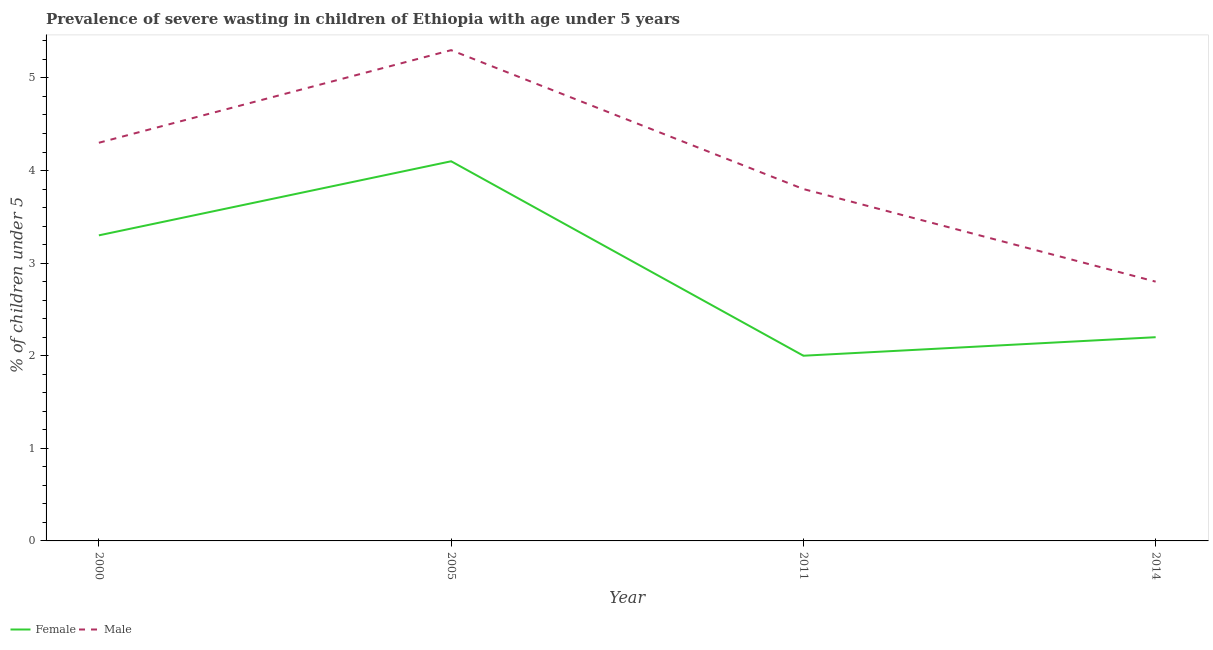What is the percentage of undernourished male children in 2000?
Provide a succinct answer. 4.3. Across all years, what is the maximum percentage of undernourished female children?
Offer a terse response. 4.1. Across all years, what is the minimum percentage of undernourished female children?
Provide a short and direct response. 2. In which year was the percentage of undernourished male children minimum?
Provide a succinct answer. 2014. What is the total percentage of undernourished female children in the graph?
Ensure brevity in your answer.  11.6. What is the difference between the percentage of undernourished female children in 2000 and that in 2014?
Offer a terse response. 1.1. What is the difference between the percentage of undernourished female children in 2014 and the percentage of undernourished male children in 2000?
Offer a terse response. -2.1. What is the average percentage of undernourished male children per year?
Your answer should be very brief. 4.05. In the year 2005, what is the difference between the percentage of undernourished male children and percentage of undernourished female children?
Provide a succinct answer. 1.2. What is the ratio of the percentage of undernourished female children in 2000 to that in 2005?
Your response must be concise. 0.8. Is the percentage of undernourished male children in 2000 less than that in 2005?
Provide a succinct answer. Yes. What is the difference between the highest and the second highest percentage of undernourished male children?
Make the answer very short. 1. What is the difference between the highest and the lowest percentage of undernourished female children?
Offer a terse response. 2.1. In how many years, is the percentage of undernourished female children greater than the average percentage of undernourished female children taken over all years?
Provide a succinct answer. 2. Is the percentage of undernourished male children strictly less than the percentage of undernourished female children over the years?
Your answer should be compact. No. How many lines are there?
Your answer should be very brief. 2. Are the values on the major ticks of Y-axis written in scientific E-notation?
Make the answer very short. No. Does the graph contain any zero values?
Provide a succinct answer. No. Does the graph contain grids?
Provide a short and direct response. No. How are the legend labels stacked?
Make the answer very short. Horizontal. What is the title of the graph?
Offer a terse response. Prevalence of severe wasting in children of Ethiopia with age under 5 years. Does "Girls" appear as one of the legend labels in the graph?
Offer a very short reply. No. What is the label or title of the Y-axis?
Offer a terse response.  % of children under 5. What is the  % of children under 5 of Female in 2000?
Offer a very short reply. 3.3. What is the  % of children under 5 of Male in 2000?
Give a very brief answer. 4.3. What is the  % of children under 5 of Female in 2005?
Make the answer very short. 4.1. What is the  % of children under 5 in Male in 2005?
Offer a terse response. 5.3. What is the  % of children under 5 of Male in 2011?
Offer a very short reply. 3.8. What is the  % of children under 5 of Female in 2014?
Keep it short and to the point. 2.2. What is the  % of children under 5 in Male in 2014?
Provide a short and direct response. 2.8. Across all years, what is the maximum  % of children under 5 in Female?
Your answer should be compact. 4.1. Across all years, what is the maximum  % of children under 5 of Male?
Offer a terse response. 5.3. Across all years, what is the minimum  % of children under 5 in Male?
Give a very brief answer. 2.8. What is the total  % of children under 5 of Male in the graph?
Your answer should be very brief. 16.2. What is the difference between the  % of children under 5 of Male in 2000 and that in 2005?
Make the answer very short. -1. What is the difference between the  % of children under 5 of Female in 2000 and that in 2011?
Keep it short and to the point. 1.3. What is the difference between the  % of children under 5 in Male in 2000 and that in 2011?
Your answer should be very brief. 0.5. What is the difference between the  % of children under 5 of Male in 2000 and that in 2014?
Your answer should be very brief. 1.5. What is the difference between the  % of children under 5 of Female in 2005 and that in 2011?
Ensure brevity in your answer.  2.1. What is the difference between the  % of children under 5 of Male in 2005 and that in 2011?
Offer a very short reply. 1.5. What is the difference between the  % of children under 5 in Female in 2005 and that in 2014?
Provide a succinct answer. 1.9. What is the difference between the  % of children under 5 in Male in 2005 and that in 2014?
Provide a short and direct response. 2.5. What is the difference between the  % of children under 5 of Male in 2011 and that in 2014?
Your response must be concise. 1. What is the difference between the  % of children under 5 of Female in 2000 and the  % of children under 5 of Male in 2014?
Ensure brevity in your answer.  0.5. What is the difference between the  % of children under 5 of Female in 2005 and the  % of children under 5 of Male in 2014?
Provide a succinct answer. 1.3. What is the difference between the  % of children under 5 in Female in 2011 and the  % of children under 5 in Male in 2014?
Provide a short and direct response. -0.8. What is the average  % of children under 5 in Male per year?
Provide a succinct answer. 4.05. In the year 2014, what is the difference between the  % of children under 5 in Female and  % of children under 5 in Male?
Keep it short and to the point. -0.6. What is the ratio of the  % of children under 5 in Female in 2000 to that in 2005?
Keep it short and to the point. 0.8. What is the ratio of the  % of children under 5 of Male in 2000 to that in 2005?
Offer a terse response. 0.81. What is the ratio of the  % of children under 5 in Female in 2000 to that in 2011?
Provide a short and direct response. 1.65. What is the ratio of the  % of children under 5 in Male in 2000 to that in 2011?
Make the answer very short. 1.13. What is the ratio of the  % of children under 5 of Female in 2000 to that in 2014?
Give a very brief answer. 1.5. What is the ratio of the  % of children under 5 of Male in 2000 to that in 2014?
Make the answer very short. 1.54. What is the ratio of the  % of children under 5 of Female in 2005 to that in 2011?
Ensure brevity in your answer.  2.05. What is the ratio of the  % of children under 5 of Male in 2005 to that in 2011?
Provide a short and direct response. 1.39. What is the ratio of the  % of children under 5 of Female in 2005 to that in 2014?
Make the answer very short. 1.86. What is the ratio of the  % of children under 5 in Male in 2005 to that in 2014?
Your answer should be very brief. 1.89. What is the ratio of the  % of children under 5 of Male in 2011 to that in 2014?
Offer a terse response. 1.36. What is the difference between the highest and the second highest  % of children under 5 in Female?
Offer a very short reply. 0.8. 